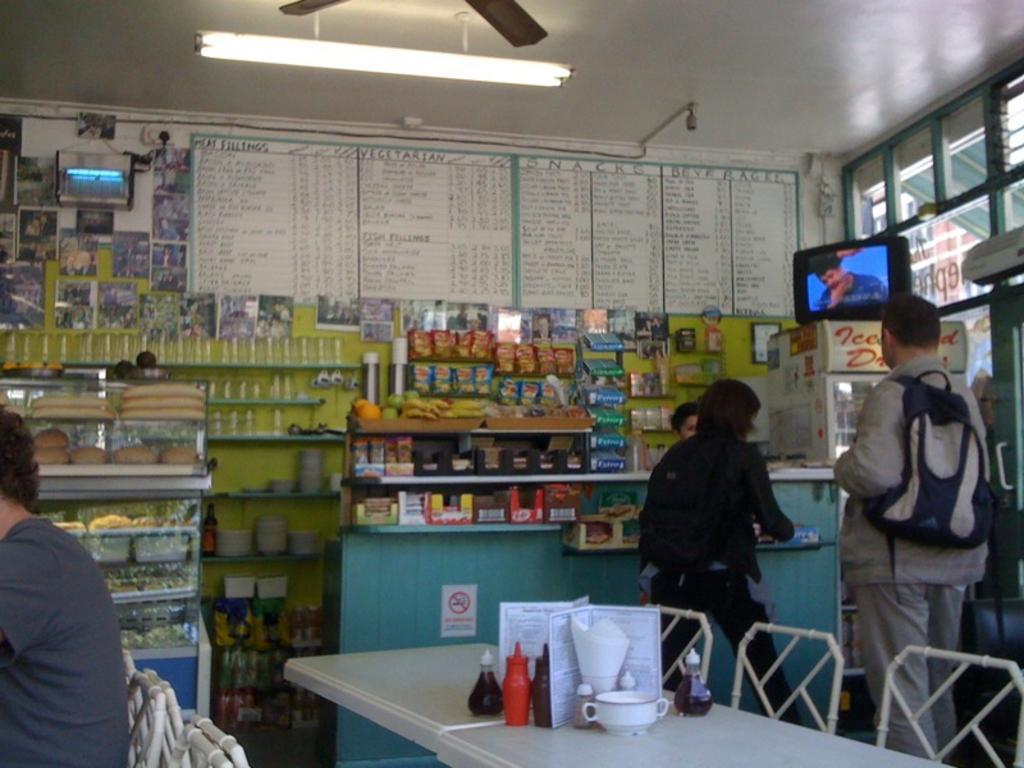Can you describe this image briefly? Here we can see two persons are standing on the floor. This is table. On the table there are bottles, and a jar. These are the chairs and there is a person sitting on the chair. These are the racks. On the background there is a wall and this is light. And there is a screen. 